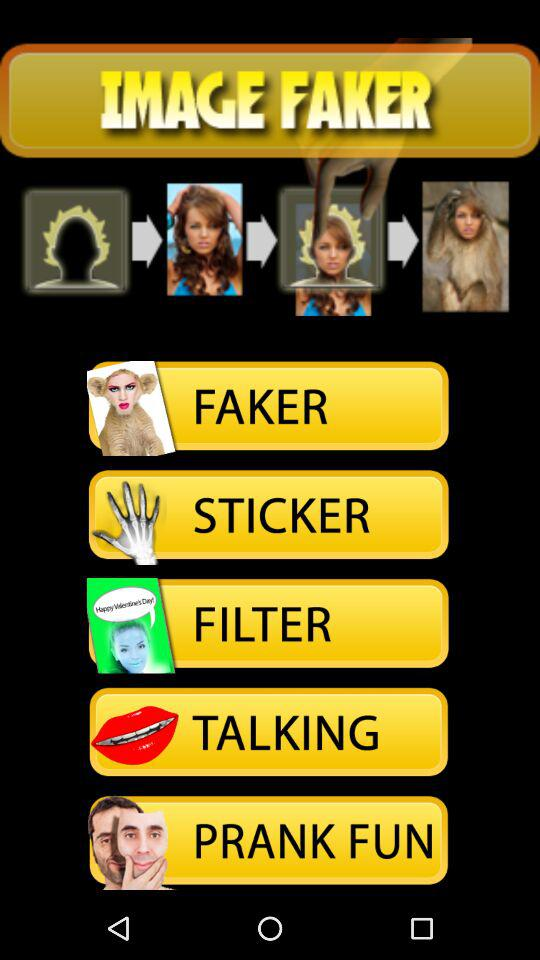What is the name of the application? The name of the application is "IMAGE FAKER". 